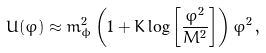<formula> <loc_0><loc_0><loc_500><loc_500>U ( \varphi ) \approx m ^ { 2 } _ { \phi } \left ( 1 + K \log \left [ \frac { \varphi ^ { 2 } } { M ^ { 2 } } \right ] \right ) \varphi ^ { 2 } \, ,</formula> 